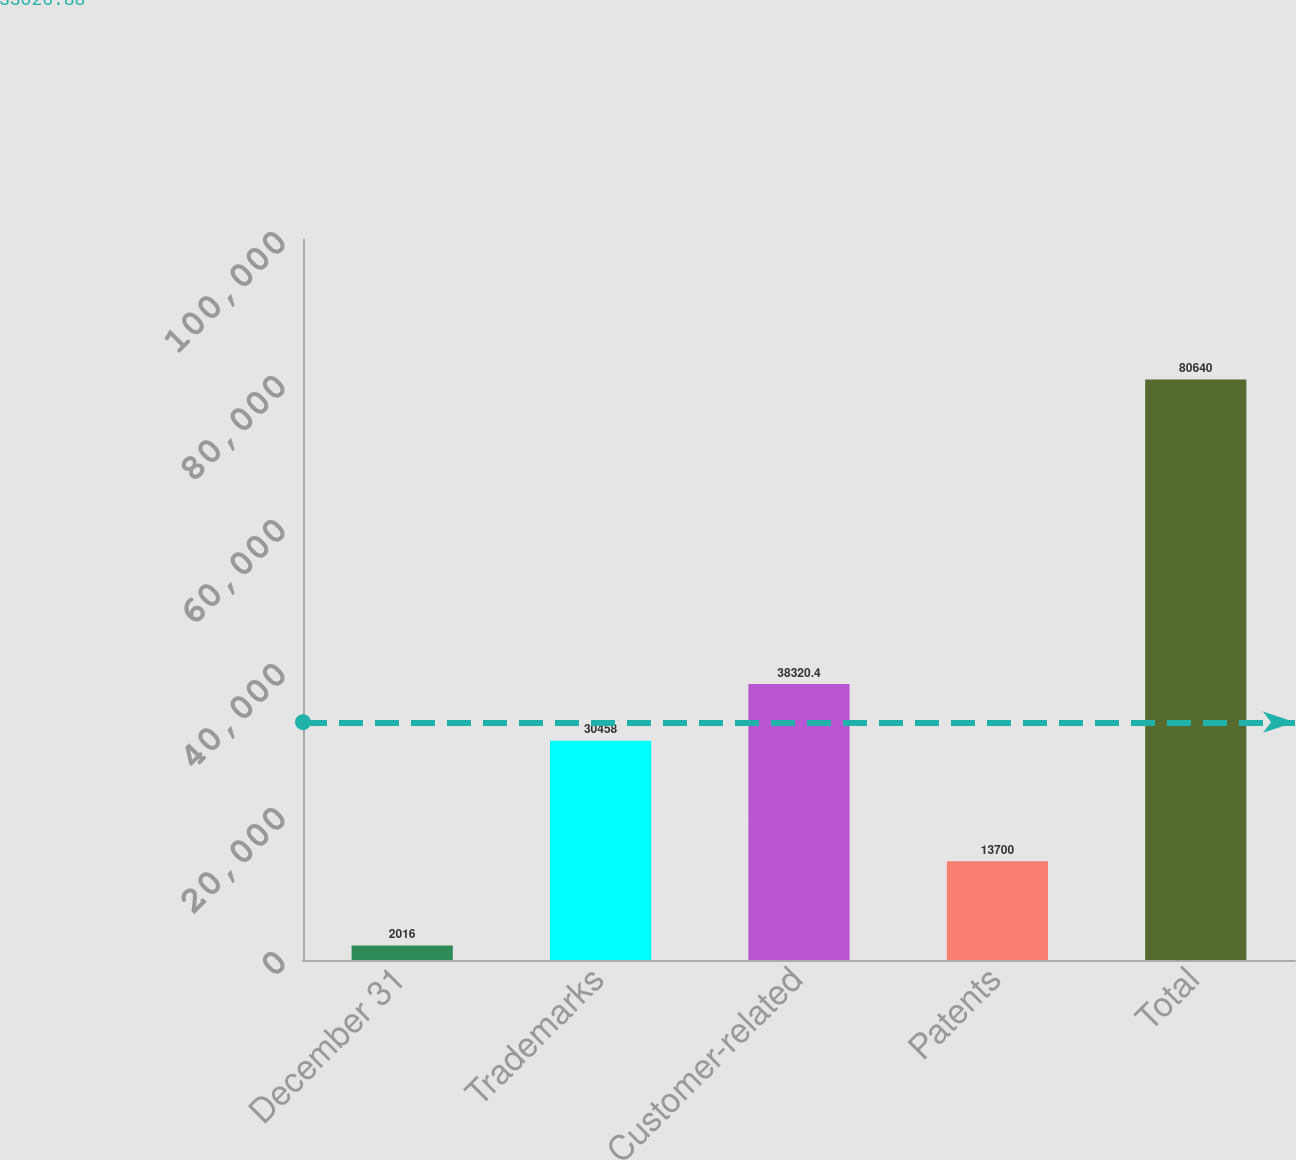<chart> <loc_0><loc_0><loc_500><loc_500><bar_chart><fcel>December 31<fcel>Trademarks<fcel>Customer-related<fcel>Patents<fcel>Total<nl><fcel>2016<fcel>30458<fcel>38320.4<fcel>13700<fcel>80640<nl></chart> 